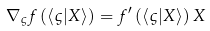<formula> <loc_0><loc_0><loc_500><loc_500>\nabla _ { \varsigma } f \left ( \left \langle \varsigma | X \right \rangle \right ) = f ^ { \prime } \left ( \left \langle \varsigma | X \right \rangle \right ) X</formula> 